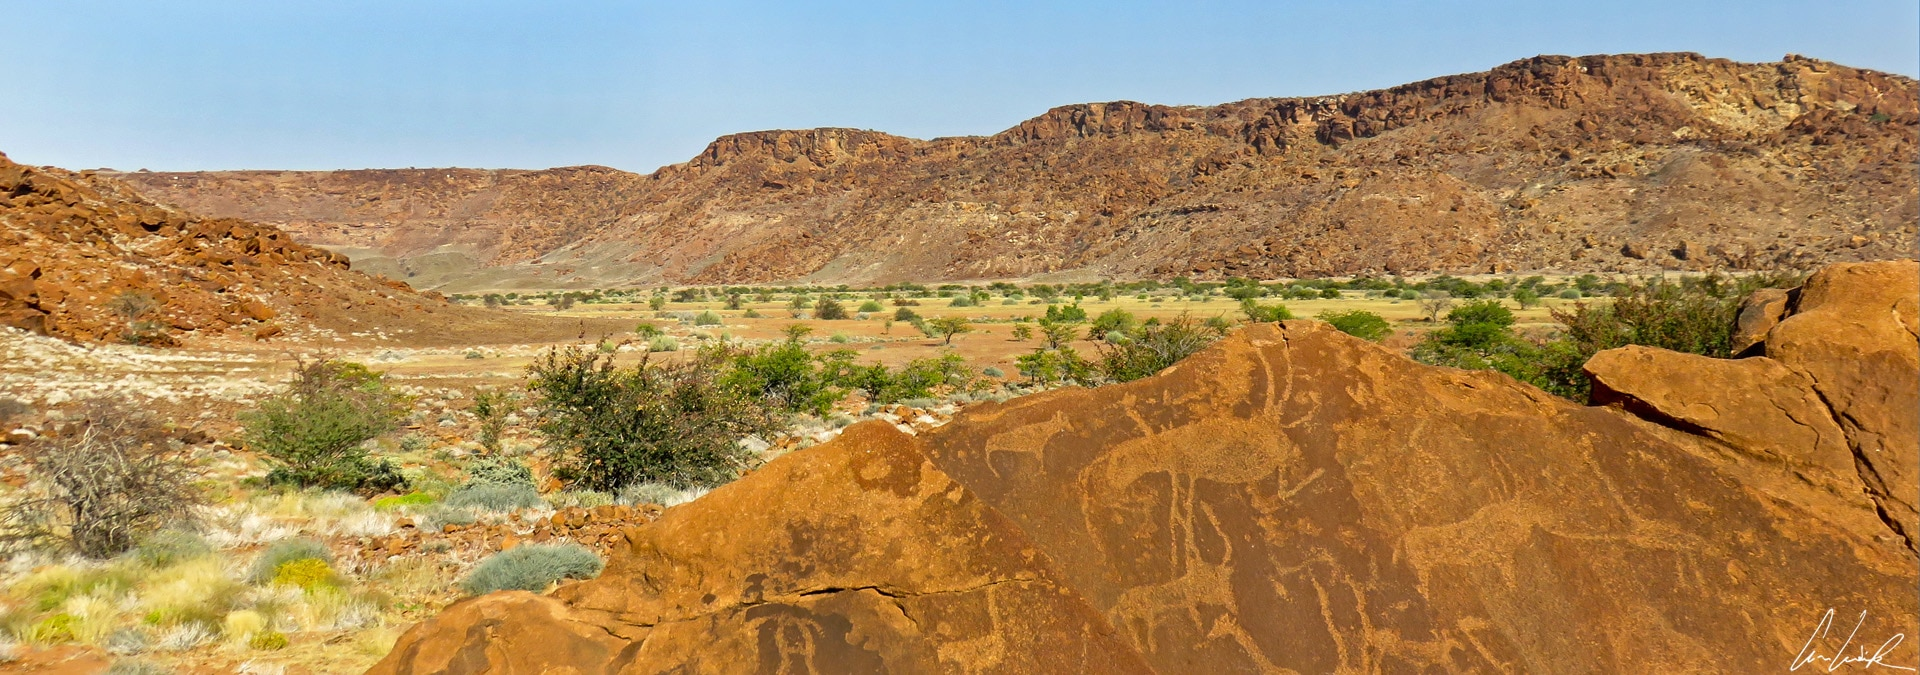If animals in the engraving could come to life, what adventures might they undertake in this vast landscape? As dawn breaks over Twyfelfontein, the animals etched into the rocks begin to stir. The giraffes, with their graceful necks, lead an expedition across the plains in search of the fabled Watering Hole of Tranquility, rumored to exist somewhere within the valley. The elands and antelopes join the journey, navigating through tricky rock formations and sparse vegetation, learning from the landscape as they go. Along the way, they encounter the wise desert tortoise who imparts secrets of survival and the majestic eagle who provides guidance from the skies. By dusk, they reach their destination, a lush oasis teeming with life, hidden from human eyes for centuries. Here, they revel in their new-found liberation, knowing that by nightfall they will return to their stone forms, eternally carrying the spirit of their epic adventure engraved in the heart of Twyfelfontein. 